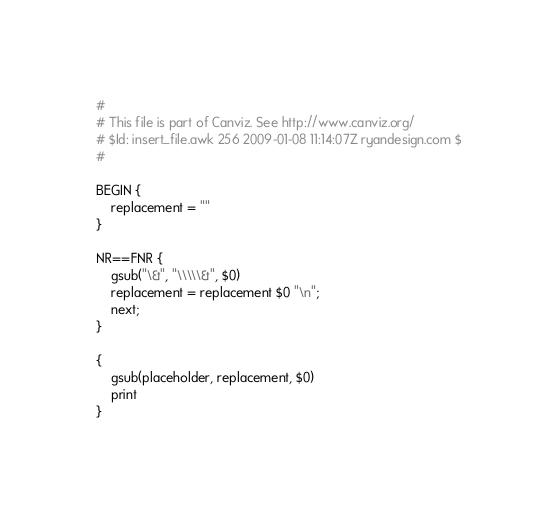Convert code to text. <code><loc_0><loc_0><loc_500><loc_500><_Awk_>#
# This file is part of Canviz. See http://www.canviz.org/
# $Id: insert_file.awk 256 2009-01-08 11:14:07Z ryandesign.com $
#

BEGIN {
	replacement = ""
}

NR==FNR {
	gsub("\&", "\\\\\&", $0)
	replacement = replacement $0 "\n";
	next;
}

{
	gsub(placeholder, replacement, $0)
	print
}
</code> 